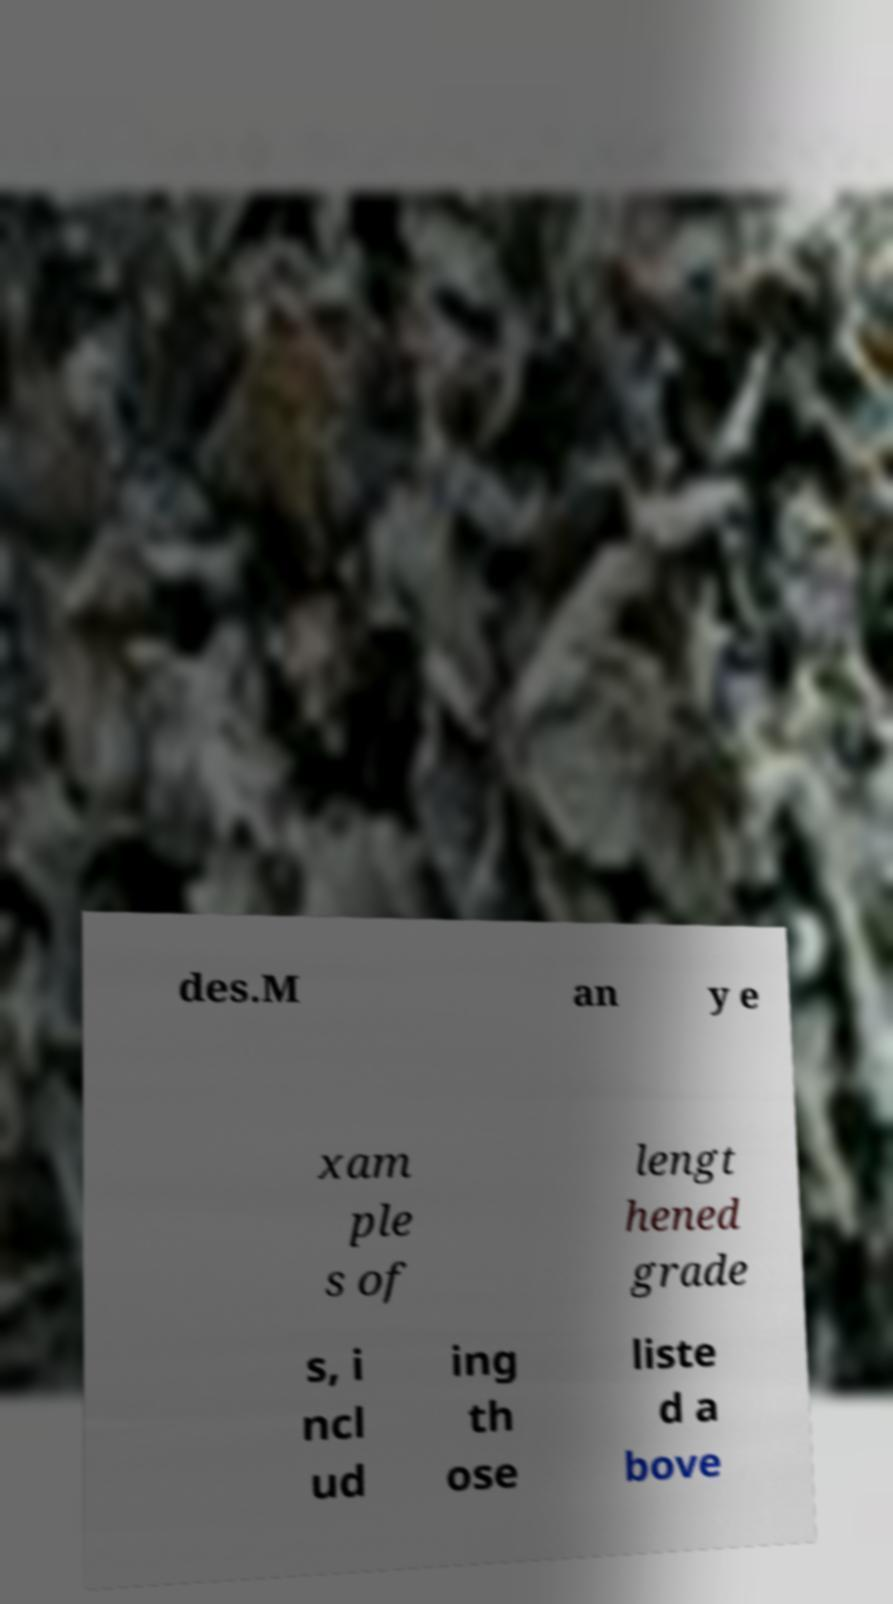Please identify and transcribe the text found in this image. des.M an y e xam ple s of lengt hened grade s, i ncl ud ing th ose liste d a bove 